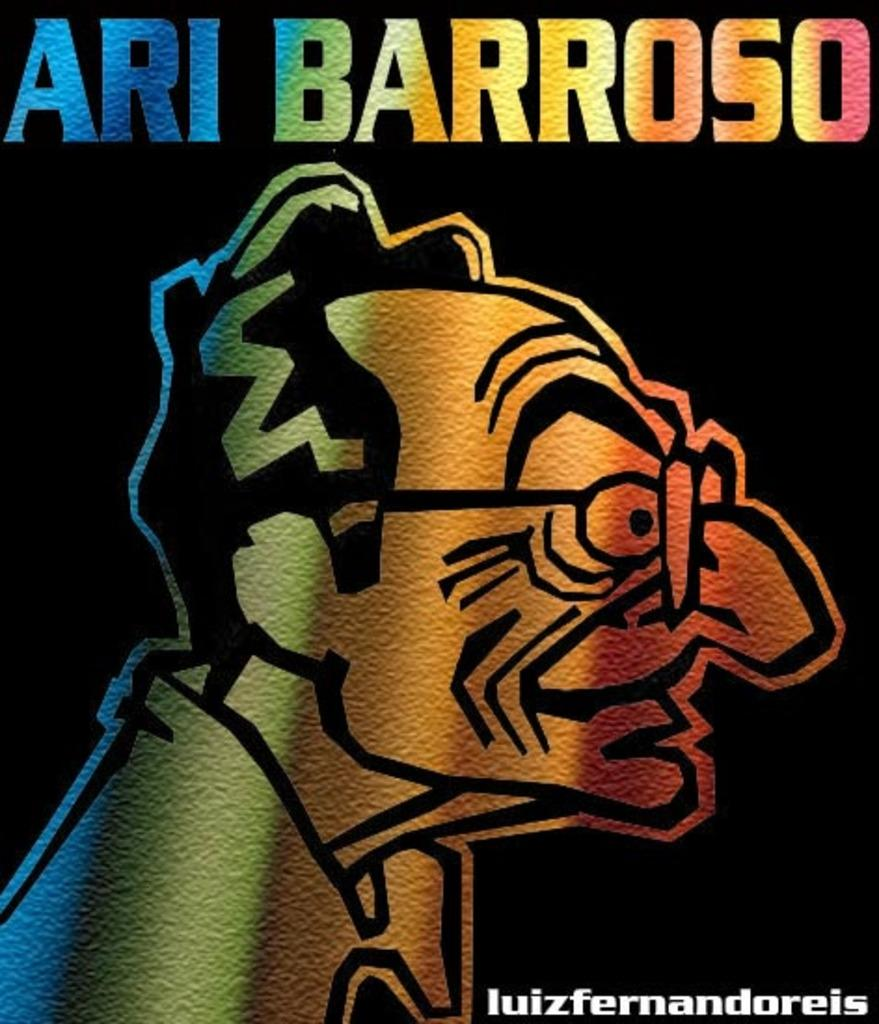<image>
Present a compact description of the photo's key features. Cover showing an evil scientists and the word "Ari Barroso" above. 